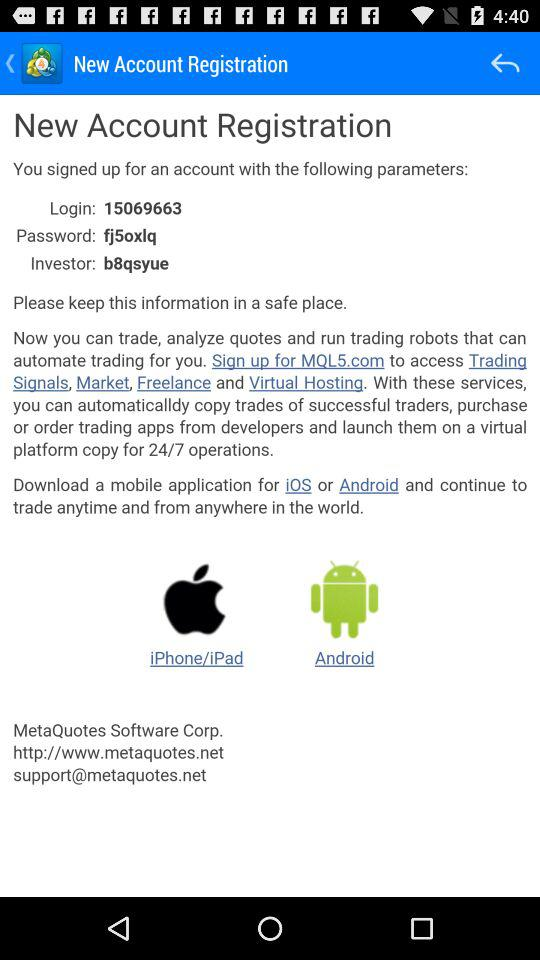What is the login number? The login number is 15069663. 